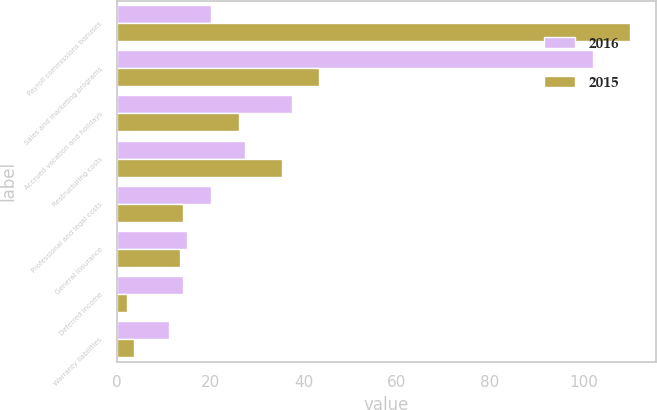Convert chart. <chart><loc_0><loc_0><loc_500><loc_500><stacked_bar_chart><ecel><fcel>Payroll commissions bonuses<fcel>Sales and marketing programs<fcel>Accrued vacation and holidays<fcel>Restructuring costs<fcel>Professional and legal costs<fcel>General insurance<fcel>Deferred income<fcel>Warranty liabilities<nl><fcel>2016<fcel>20.2<fcel>102<fcel>37.5<fcel>27.4<fcel>20.2<fcel>15<fcel>14.1<fcel>11.2<nl><fcel>2015<fcel>110<fcel>43.3<fcel>26.1<fcel>35.4<fcel>14.3<fcel>13.5<fcel>2.2<fcel>3.8<nl></chart> 